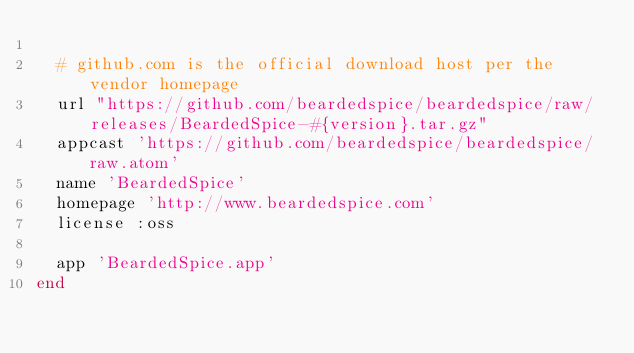<code> <loc_0><loc_0><loc_500><loc_500><_Ruby_>
  # github.com is the official download host per the vendor homepage
  url "https://github.com/beardedspice/beardedspice/raw/releases/BeardedSpice-#{version}.tar.gz"
  appcast 'https://github.com/beardedspice/beardedspice/raw.atom'
  name 'BeardedSpice'
  homepage 'http://www.beardedspice.com'
  license :oss

  app 'BeardedSpice.app'
end
</code> 